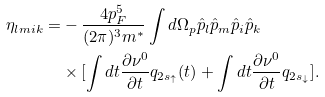Convert formula to latex. <formula><loc_0><loc_0><loc_500><loc_500>\eta _ { l m i k } = & - \frac { 4 p _ { F } ^ { 5 } } { ( 2 \pi ) ^ { 3 } m ^ { * } } \int d \Omega _ { p } \hat { p } _ { l } \hat { p } _ { m } \hat { p } _ { i } \hat { p } _ { k } \\ & \times [ \int d t \frac { \partial \nu ^ { 0 } } { \partial t } q _ { 2 s _ { \uparrow } } ( t ) + \int d t \frac { \partial \nu ^ { 0 } } { \partial t } q _ { 2 s _ { \downarrow } } ] .</formula> 